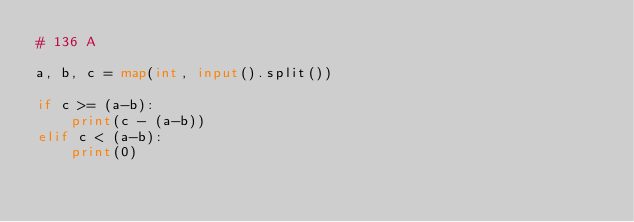Convert code to text. <code><loc_0><loc_0><loc_500><loc_500><_Python_># 136 A

a, b, c = map(int, input().split())

if c >= (a-b):  
    print(c - (a-b))
elif c < (a-b):
    print(0)</code> 